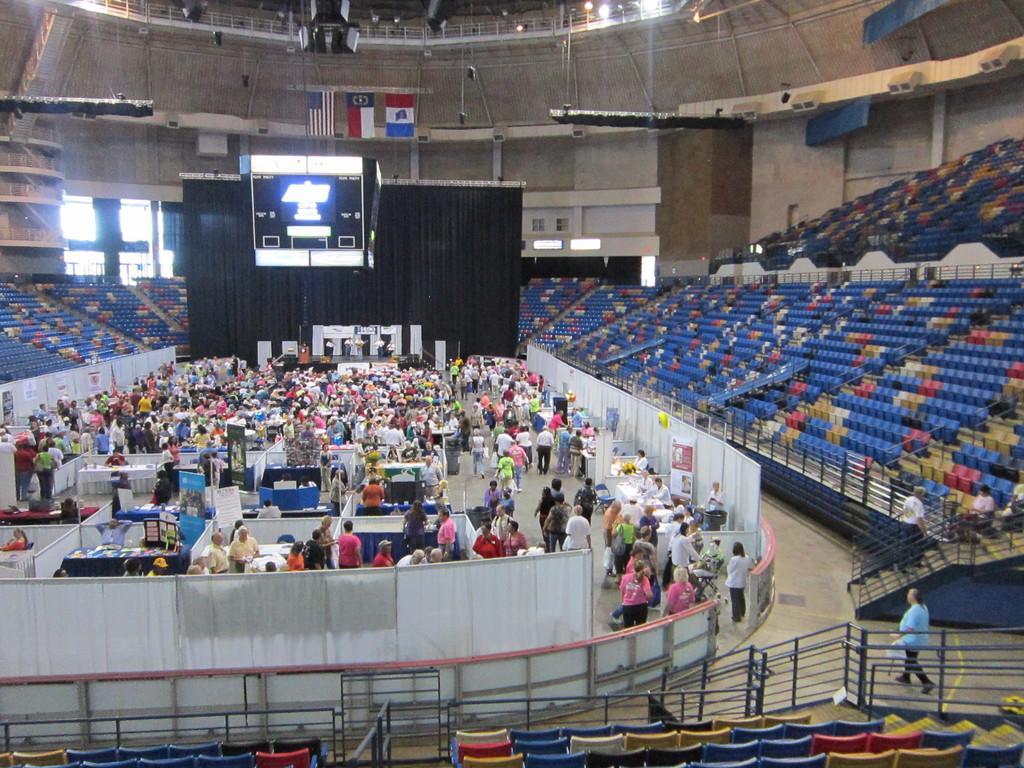Can you describe this image briefly? In the picture I can see few persons standing and there are some other objects beside them and there are few televisions above them and there are few empty chairs around them. 